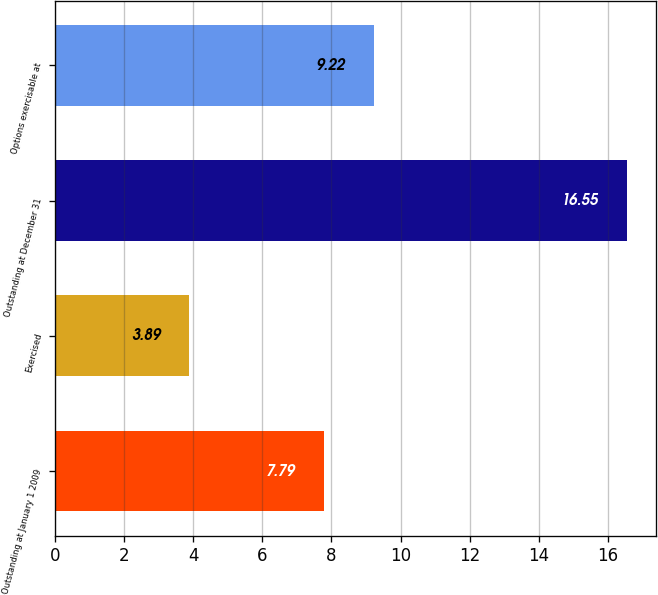<chart> <loc_0><loc_0><loc_500><loc_500><bar_chart><fcel>Outstanding at January 1 2009<fcel>Exercised<fcel>Outstanding at December 31<fcel>Options exercisable at<nl><fcel>7.79<fcel>3.89<fcel>16.55<fcel>9.22<nl></chart> 